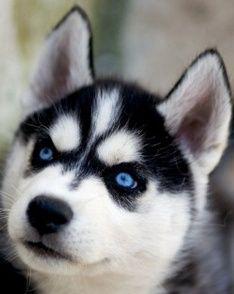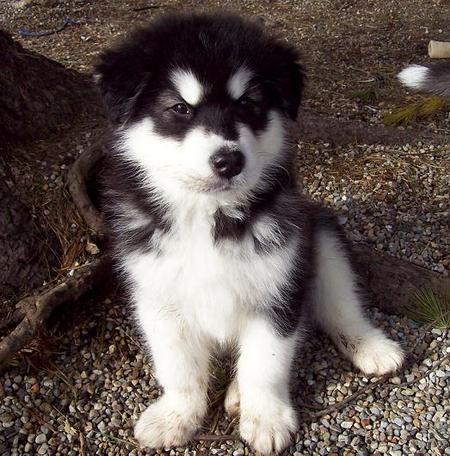The first image is the image on the left, the second image is the image on the right. Considering the images on both sides, is "At least one of the dogs is opening its mouth." valid? Answer yes or no. No. The first image is the image on the left, the second image is the image on the right. For the images displayed, is the sentence "At least one dog has blue eyes." factually correct? Answer yes or no. Yes. 